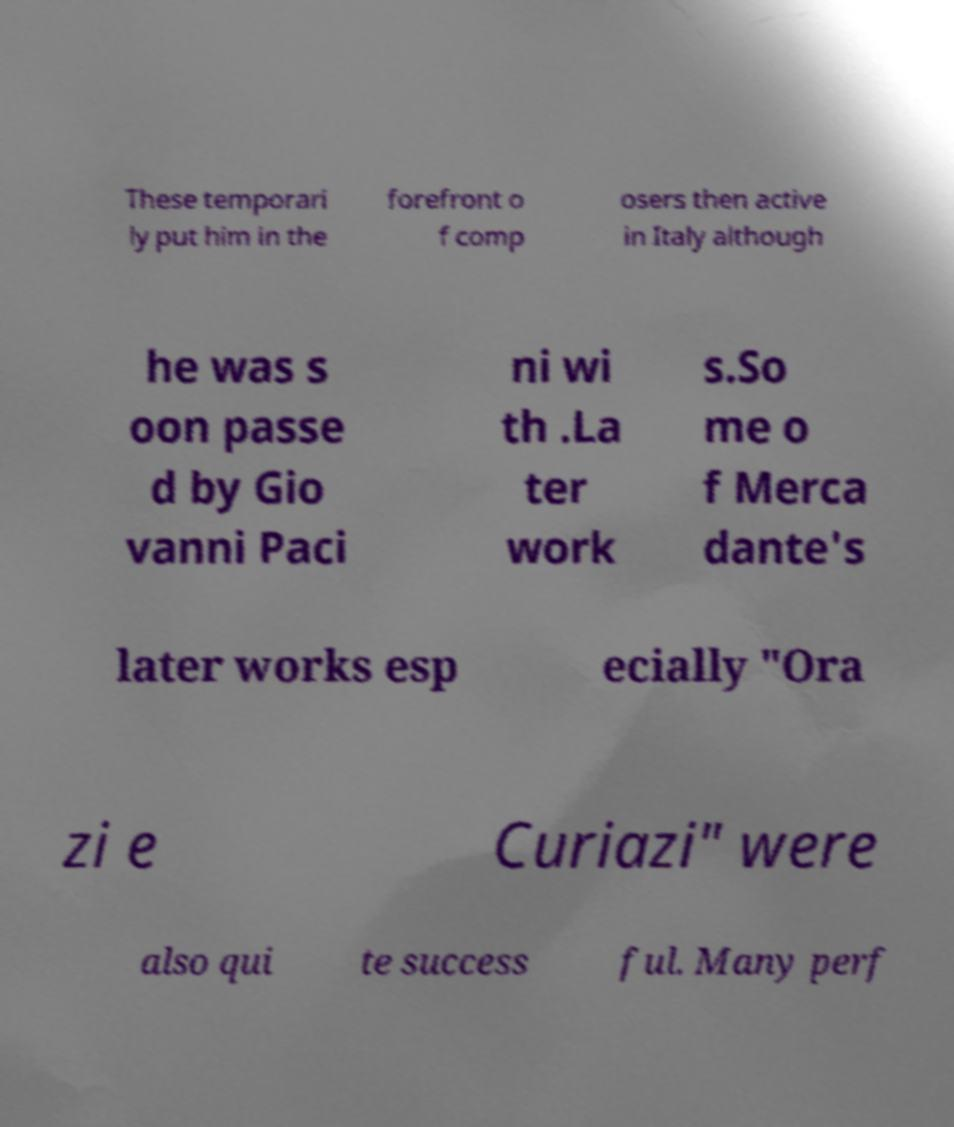Please read and relay the text visible in this image. What does it say? These temporari ly put him in the forefront o f comp osers then active in Italy although he was s oon passe d by Gio vanni Paci ni wi th .La ter work s.So me o f Merca dante's later works esp ecially "Ora zi e Curiazi" were also qui te success ful. Many perf 